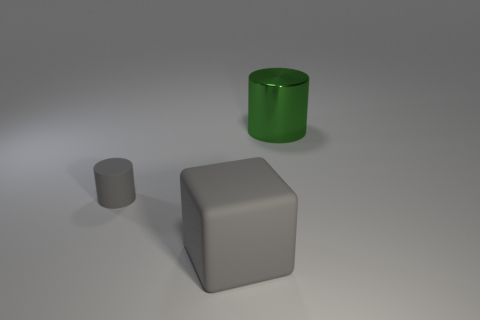Add 1 large cyan matte cylinders. How many objects exist? 4 Subtract all cubes. How many objects are left? 2 Subtract all big brown metal cubes. Subtract all big things. How many objects are left? 1 Add 1 green metallic cylinders. How many green metallic cylinders are left? 2 Add 2 large green things. How many large green things exist? 3 Subtract 0 yellow balls. How many objects are left? 3 